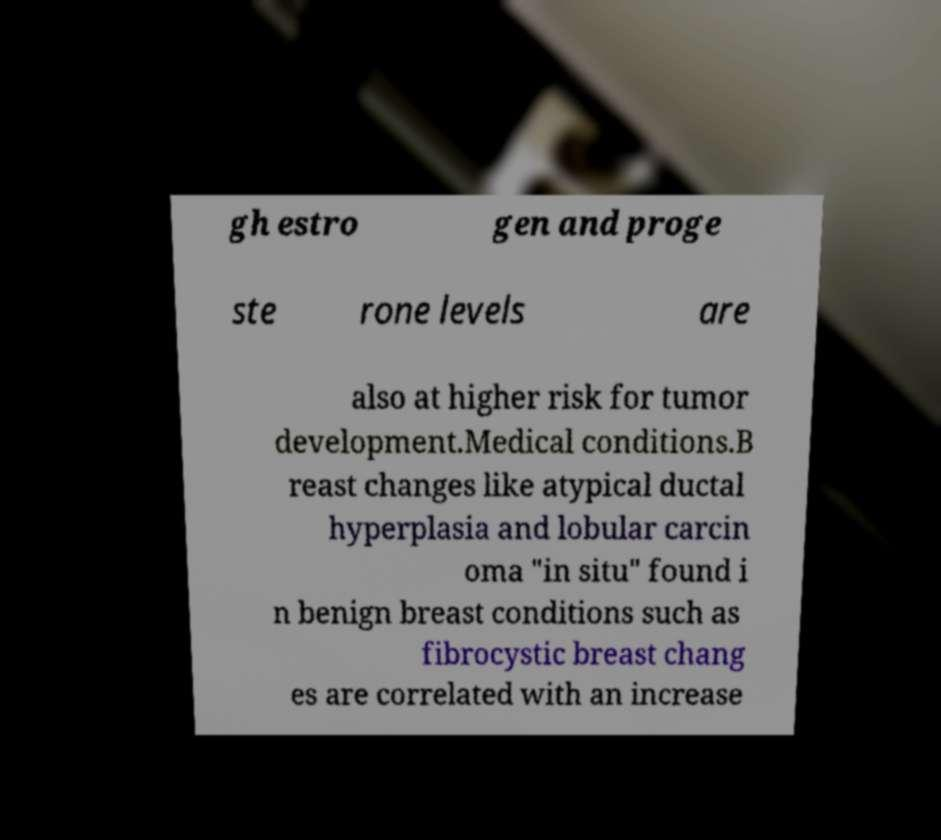I need the written content from this picture converted into text. Can you do that? gh estro gen and proge ste rone levels are also at higher risk for tumor development.Medical conditions.B reast changes like atypical ductal hyperplasia and lobular carcin oma "in situ" found i n benign breast conditions such as fibrocystic breast chang es are correlated with an increase 